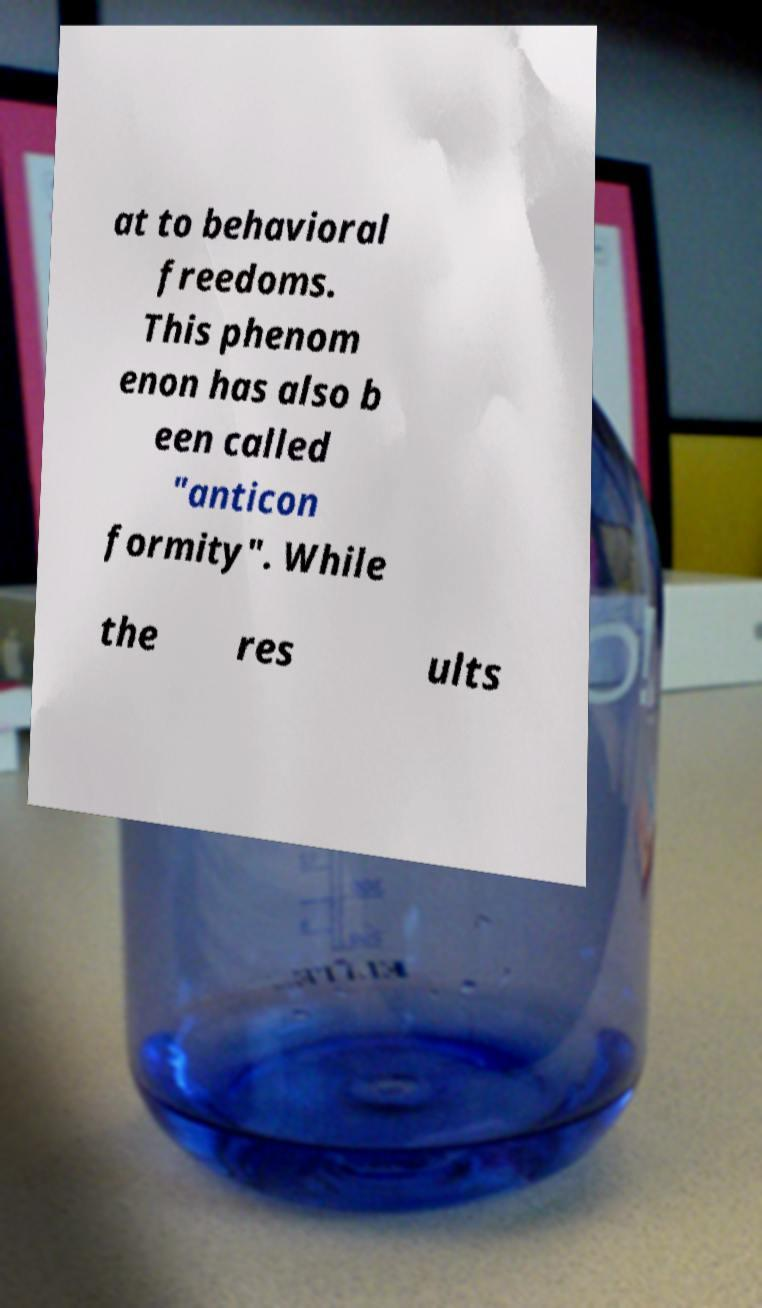Can you accurately transcribe the text from the provided image for me? at to behavioral freedoms. This phenom enon has also b een called "anticon formity". While the res ults 